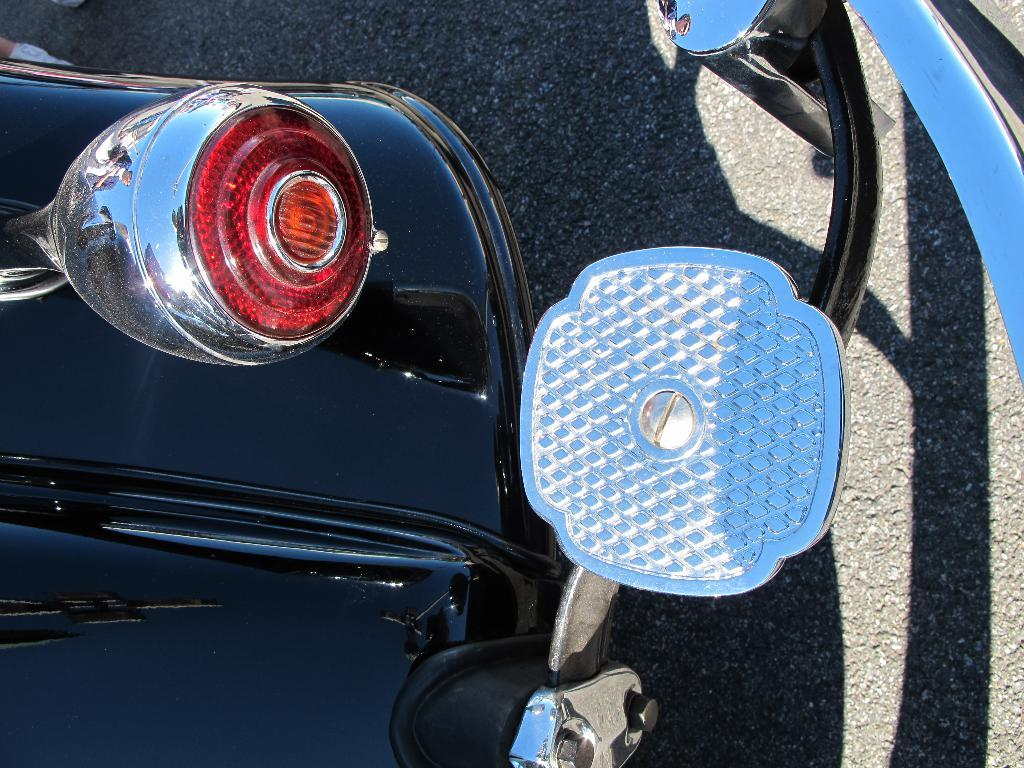What is the main subject of the picture? The main subject of the picture is a vehicle. What can be seen in the background of the picture? There is a road in the background of the picture. Where is the light located in the picture? The light is on the left side of the picture. What type of guitar can be seen hanging from the vehicle in the image? There is no guitar present in the image; it only features a vehicle, a road in the background, and a light on the left side. 